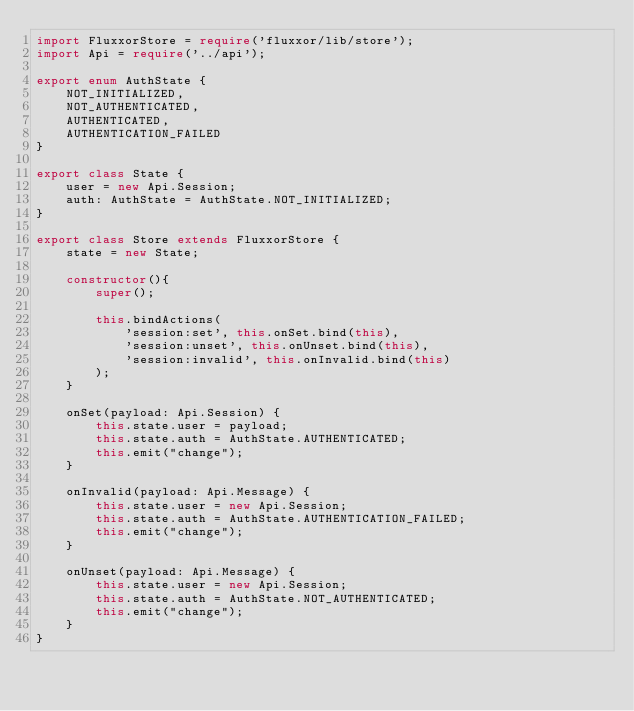Convert code to text. <code><loc_0><loc_0><loc_500><loc_500><_TypeScript_>import FluxxorStore = require('fluxxor/lib/store');
import Api = require('../api');

export enum AuthState {
    NOT_INITIALIZED,
    NOT_AUTHENTICATED,
    AUTHENTICATED,
    AUTHENTICATION_FAILED
}

export class State {
    user = new Api.Session;
    auth: AuthState = AuthState.NOT_INITIALIZED;
}

export class Store extends FluxxorStore {
    state = new State;
    
    constructor(){
        super();
        
        this.bindActions(
            'session:set', this.onSet.bind(this),
            'session:unset', this.onUnset.bind(this),
            'session:invalid', this.onInvalid.bind(this)
        );
    }
    
    onSet(payload: Api.Session) {
        this.state.user = payload;
        this.state.auth = AuthState.AUTHENTICATED;
        this.emit("change");
    }
    
    onInvalid(payload: Api.Message) {
        this.state.user = new Api.Session;
        this.state.auth = AuthState.AUTHENTICATION_FAILED;
        this.emit("change");
    }
    
    onUnset(payload: Api.Message) {
        this.state.user = new Api.Session;
        this.state.auth = AuthState.NOT_AUTHENTICATED;
        this.emit("change");
    }
}
</code> 